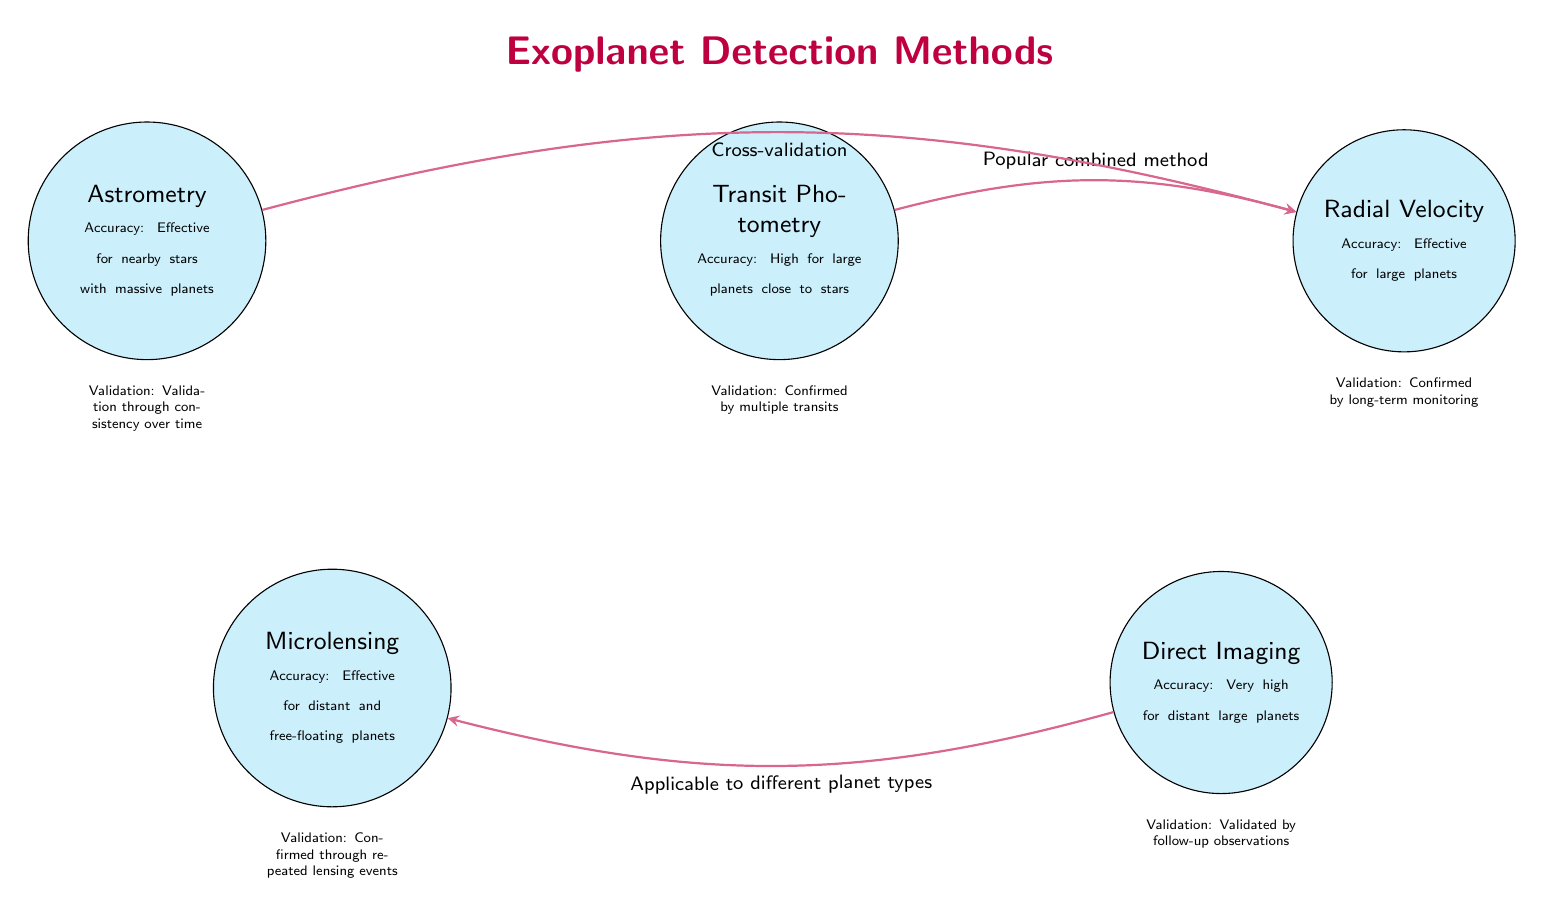What is the accuracy for Transit Photometry? The diagram states that the accuracy for Transit Photometry is high for large planets close to stars.
Answer: High for large planets close to stars What is the validation method for Radial Velocity? According to the diagram, Radial Velocity's validation is confirmed by long-term monitoring.
Answer: Confirmed by long-term monitoring How many detection methods are shown in the diagram? The diagram displays a total of five detection methods: Transit Photometry, Radial Velocity, Direct Imaging, Microlensing, and Astrometry.
Answer: Five What is the main connection type between Transit Photometry and Radial Velocity? The diagram indicates a connection labeled "Popular combined method" between Transit Photometry and Radial Velocity.
Answer: Popular combined method Which detection method is effective for nearby stars with massive planets? The description for Astrometry in the diagram mentions it is effective for nearby stars with massive planets.
Answer: Astrometry What is the accuracy note associated with Direct Imaging? The diagram states that Direct Imaging has very high accuracy for distant large planets.
Answer: Very high for distant large planets What is the relationship between Astrometry and Radial Velocity in terms of validation? The diagram shows that Astrometry has a cross-validation relationship with Radial Velocity.
Answer: Cross-validation What kind of planets does Microlensing effectively detect? The diagram states that Microlensing is effective for distant and free-floating planets.
Answer: Distant and free-floating planets What is the accuracy note given for Microlensing? According to the diagram, Microlensing is effective for distant and free-floating planets, indicating its accuracy in those scenarios.
Answer: Effective for distant and free-floating planets 